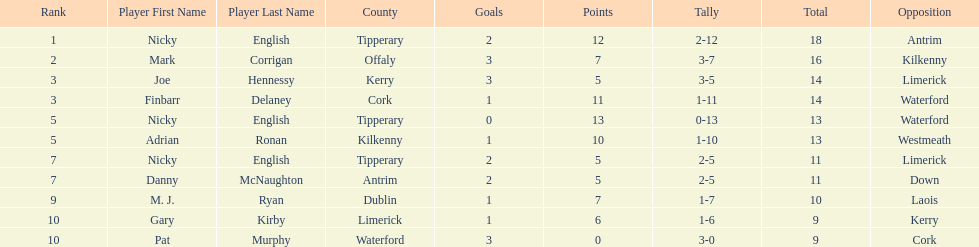If you added all the total's up, what would the number be? 138. 